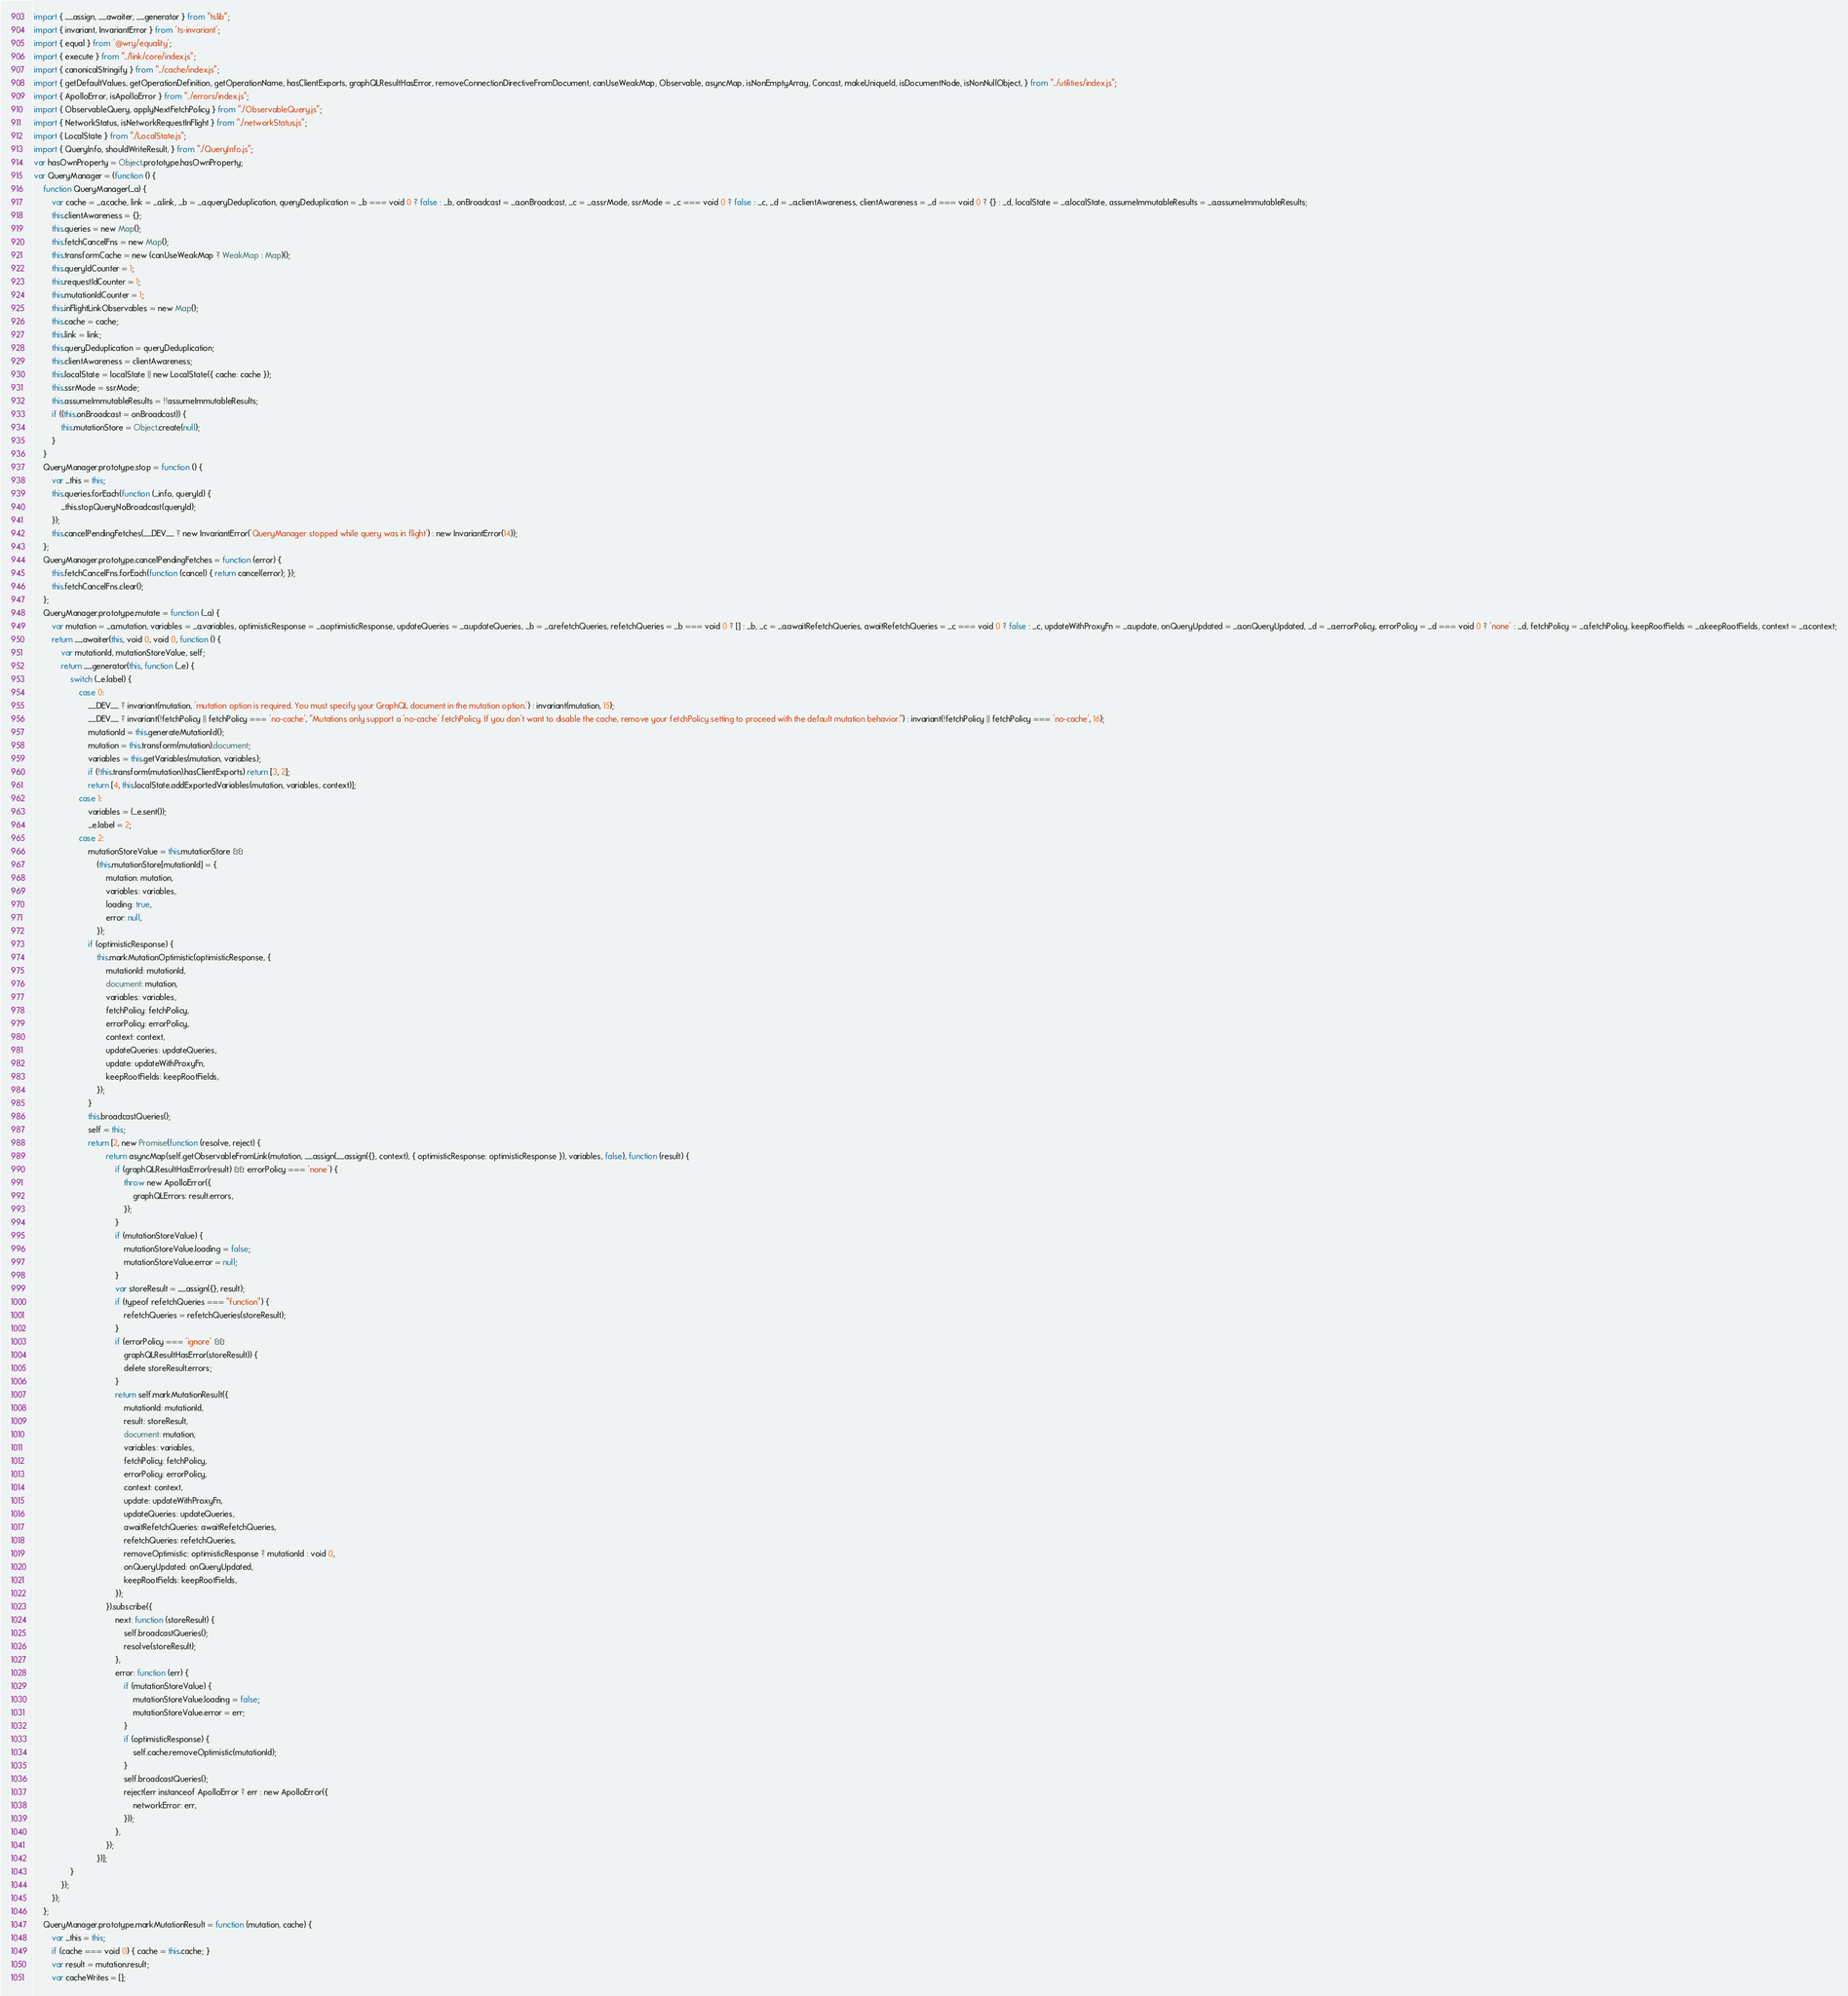Convert code to text. <code><loc_0><loc_0><loc_500><loc_500><_JavaScript_>import { __assign, __awaiter, __generator } from "tslib";
import { invariant, InvariantError } from 'ts-invariant';
import { equal } from '@wry/equality';
import { execute } from "../link/core/index.js";
import { canonicalStringify } from "../cache/index.js";
import { getDefaultValues, getOperationDefinition, getOperationName, hasClientExports, graphQLResultHasError, removeConnectionDirectiveFromDocument, canUseWeakMap, Observable, asyncMap, isNonEmptyArray, Concast, makeUniqueId, isDocumentNode, isNonNullObject, } from "../utilities/index.js";
import { ApolloError, isApolloError } from "../errors/index.js";
import { ObservableQuery, applyNextFetchPolicy } from "./ObservableQuery.js";
import { NetworkStatus, isNetworkRequestInFlight } from "./networkStatus.js";
import { LocalState } from "./LocalState.js";
import { QueryInfo, shouldWriteResult, } from "./QueryInfo.js";
var hasOwnProperty = Object.prototype.hasOwnProperty;
var QueryManager = (function () {
    function QueryManager(_a) {
        var cache = _a.cache, link = _a.link, _b = _a.queryDeduplication, queryDeduplication = _b === void 0 ? false : _b, onBroadcast = _a.onBroadcast, _c = _a.ssrMode, ssrMode = _c === void 0 ? false : _c, _d = _a.clientAwareness, clientAwareness = _d === void 0 ? {} : _d, localState = _a.localState, assumeImmutableResults = _a.assumeImmutableResults;
        this.clientAwareness = {};
        this.queries = new Map();
        this.fetchCancelFns = new Map();
        this.transformCache = new (canUseWeakMap ? WeakMap : Map)();
        this.queryIdCounter = 1;
        this.requestIdCounter = 1;
        this.mutationIdCounter = 1;
        this.inFlightLinkObservables = new Map();
        this.cache = cache;
        this.link = link;
        this.queryDeduplication = queryDeduplication;
        this.clientAwareness = clientAwareness;
        this.localState = localState || new LocalState({ cache: cache });
        this.ssrMode = ssrMode;
        this.assumeImmutableResults = !!assumeImmutableResults;
        if ((this.onBroadcast = onBroadcast)) {
            this.mutationStore = Object.create(null);
        }
    }
    QueryManager.prototype.stop = function () {
        var _this = this;
        this.queries.forEach(function (_info, queryId) {
            _this.stopQueryNoBroadcast(queryId);
        });
        this.cancelPendingFetches(__DEV__ ? new InvariantError('QueryManager stopped while query was in flight') : new InvariantError(14));
    };
    QueryManager.prototype.cancelPendingFetches = function (error) {
        this.fetchCancelFns.forEach(function (cancel) { return cancel(error); });
        this.fetchCancelFns.clear();
    };
    QueryManager.prototype.mutate = function (_a) {
        var mutation = _a.mutation, variables = _a.variables, optimisticResponse = _a.optimisticResponse, updateQueries = _a.updateQueries, _b = _a.refetchQueries, refetchQueries = _b === void 0 ? [] : _b, _c = _a.awaitRefetchQueries, awaitRefetchQueries = _c === void 0 ? false : _c, updateWithProxyFn = _a.update, onQueryUpdated = _a.onQueryUpdated, _d = _a.errorPolicy, errorPolicy = _d === void 0 ? 'none' : _d, fetchPolicy = _a.fetchPolicy, keepRootFields = _a.keepRootFields, context = _a.context;
        return __awaiter(this, void 0, void 0, function () {
            var mutationId, mutationStoreValue, self;
            return __generator(this, function (_e) {
                switch (_e.label) {
                    case 0:
                        __DEV__ ? invariant(mutation, 'mutation option is required. You must specify your GraphQL document in the mutation option.') : invariant(mutation, 15);
                        __DEV__ ? invariant(!fetchPolicy || fetchPolicy === 'no-cache', "Mutations only support a 'no-cache' fetchPolicy. If you don't want to disable the cache, remove your fetchPolicy setting to proceed with the default mutation behavior.") : invariant(!fetchPolicy || fetchPolicy === 'no-cache', 16);
                        mutationId = this.generateMutationId();
                        mutation = this.transform(mutation).document;
                        variables = this.getVariables(mutation, variables);
                        if (!this.transform(mutation).hasClientExports) return [3, 2];
                        return [4, this.localState.addExportedVariables(mutation, variables, context)];
                    case 1:
                        variables = (_e.sent());
                        _e.label = 2;
                    case 2:
                        mutationStoreValue = this.mutationStore &&
                            (this.mutationStore[mutationId] = {
                                mutation: mutation,
                                variables: variables,
                                loading: true,
                                error: null,
                            });
                        if (optimisticResponse) {
                            this.markMutationOptimistic(optimisticResponse, {
                                mutationId: mutationId,
                                document: mutation,
                                variables: variables,
                                fetchPolicy: fetchPolicy,
                                errorPolicy: errorPolicy,
                                context: context,
                                updateQueries: updateQueries,
                                update: updateWithProxyFn,
                                keepRootFields: keepRootFields,
                            });
                        }
                        this.broadcastQueries();
                        self = this;
                        return [2, new Promise(function (resolve, reject) {
                                return asyncMap(self.getObservableFromLink(mutation, __assign(__assign({}, context), { optimisticResponse: optimisticResponse }), variables, false), function (result) {
                                    if (graphQLResultHasError(result) && errorPolicy === 'none') {
                                        throw new ApolloError({
                                            graphQLErrors: result.errors,
                                        });
                                    }
                                    if (mutationStoreValue) {
                                        mutationStoreValue.loading = false;
                                        mutationStoreValue.error = null;
                                    }
                                    var storeResult = __assign({}, result);
                                    if (typeof refetchQueries === "function") {
                                        refetchQueries = refetchQueries(storeResult);
                                    }
                                    if (errorPolicy === 'ignore' &&
                                        graphQLResultHasError(storeResult)) {
                                        delete storeResult.errors;
                                    }
                                    return self.markMutationResult({
                                        mutationId: mutationId,
                                        result: storeResult,
                                        document: mutation,
                                        variables: variables,
                                        fetchPolicy: fetchPolicy,
                                        errorPolicy: errorPolicy,
                                        context: context,
                                        update: updateWithProxyFn,
                                        updateQueries: updateQueries,
                                        awaitRefetchQueries: awaitRefetchQueries,
                                        refetchQueries: refetchQueries,
                                        removeOptimistic: optimisticResponse ? mutationId : void 0,
                                        onQueryUpdated: onQueryUpdated,
                                        keepRootFields: keepRootFields,
                                    });
                                }).subscribe({
                                    next: function (storeResult) {
                                        self.broadcastQueries();
                                        resolve(storeResult);
                                    },
                                    error: function (err) {
                                        if (mutationStoreValue) {
                                            mutationStoreValue.loading = false;
                                            mutationStoreValue.error = err;
                                        }
                                        if (optimisticResponse) {
                                            self.cache.removeOptimistic(mutationId);
                                        }
                                        self.broadcastQueries();
                                        reject(err instanceof ApolloError ? err : new ApolloError({
                                            networkError: err,
                                        }));
                                    },
                                });
                            })];
                }
            });
        });
    };
    QueryManager.prototype.markMutationResult = function (mutation, cache) {
        var _this = this;
        if (cache === void 0) { cache = this.cache; }
        var result = mutation.result;
        var cacheWrites = [];</code> 